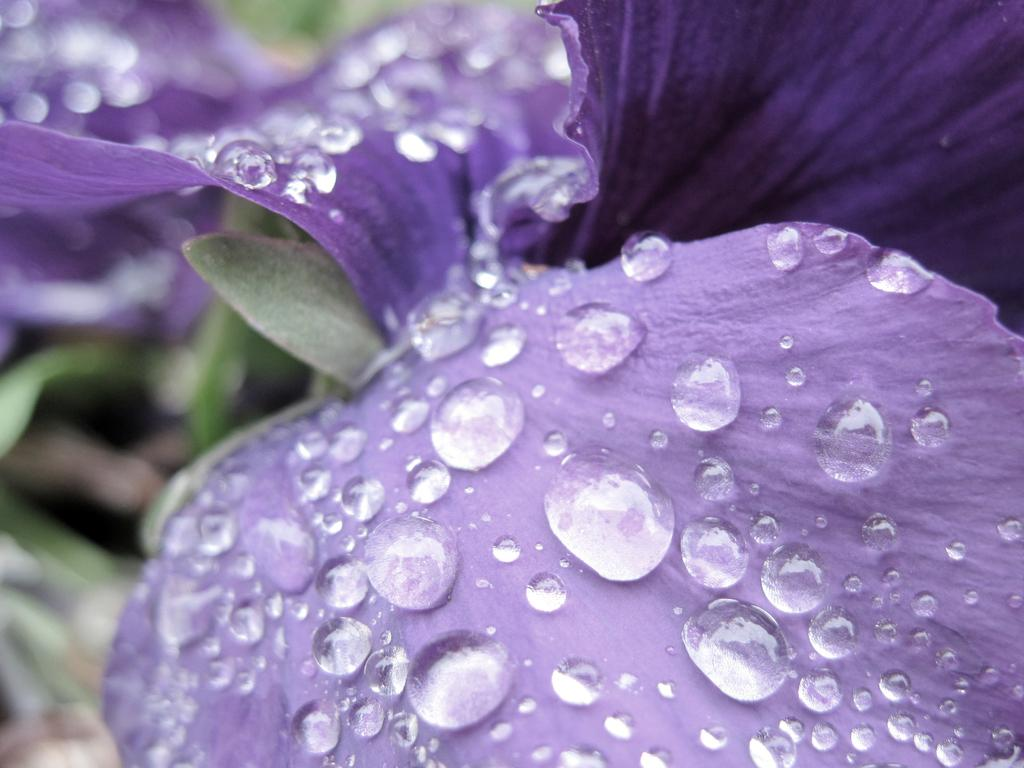What is the main subject of the image? The main subject of the image is a flower. What can be observed on the flower in the image? There are water drops on the flower in the image. What type of mass can be seen on the coast in the image? There is no coast or mass present in the image; it features a flower with water drops. What riddle can be solved using the information in the image? There is no riddle present in the image; it simply shows a flower with water drops. 